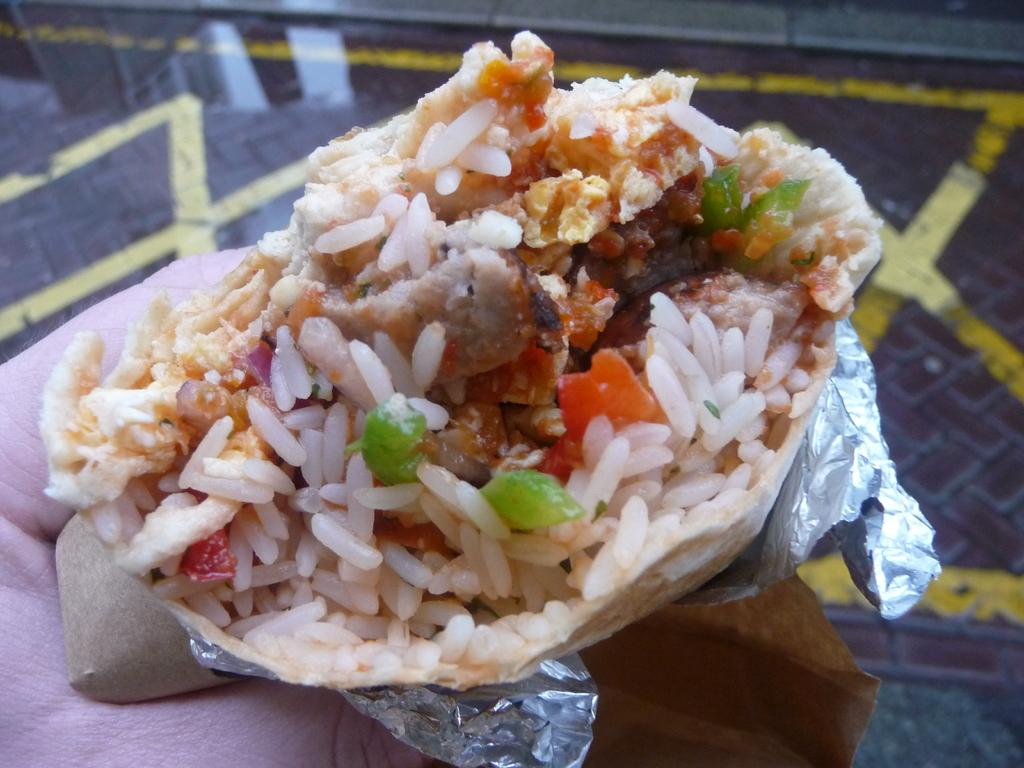What is the main subject of the image? There is a person in the image. What is the person holding in the image? The person is holding food items wrapped in aluminum foil. What else can be seen in the image besides the person and the food items? There is a paper visible in the image. What type of surface is visible in the image? There is a floor visible in the image. What type of coach can be seen in the image? There is no coach present in the image. What is the zinc content of the food items wrapped in aluminum foil? The zinc content of the food items cannot be determined from the image. 